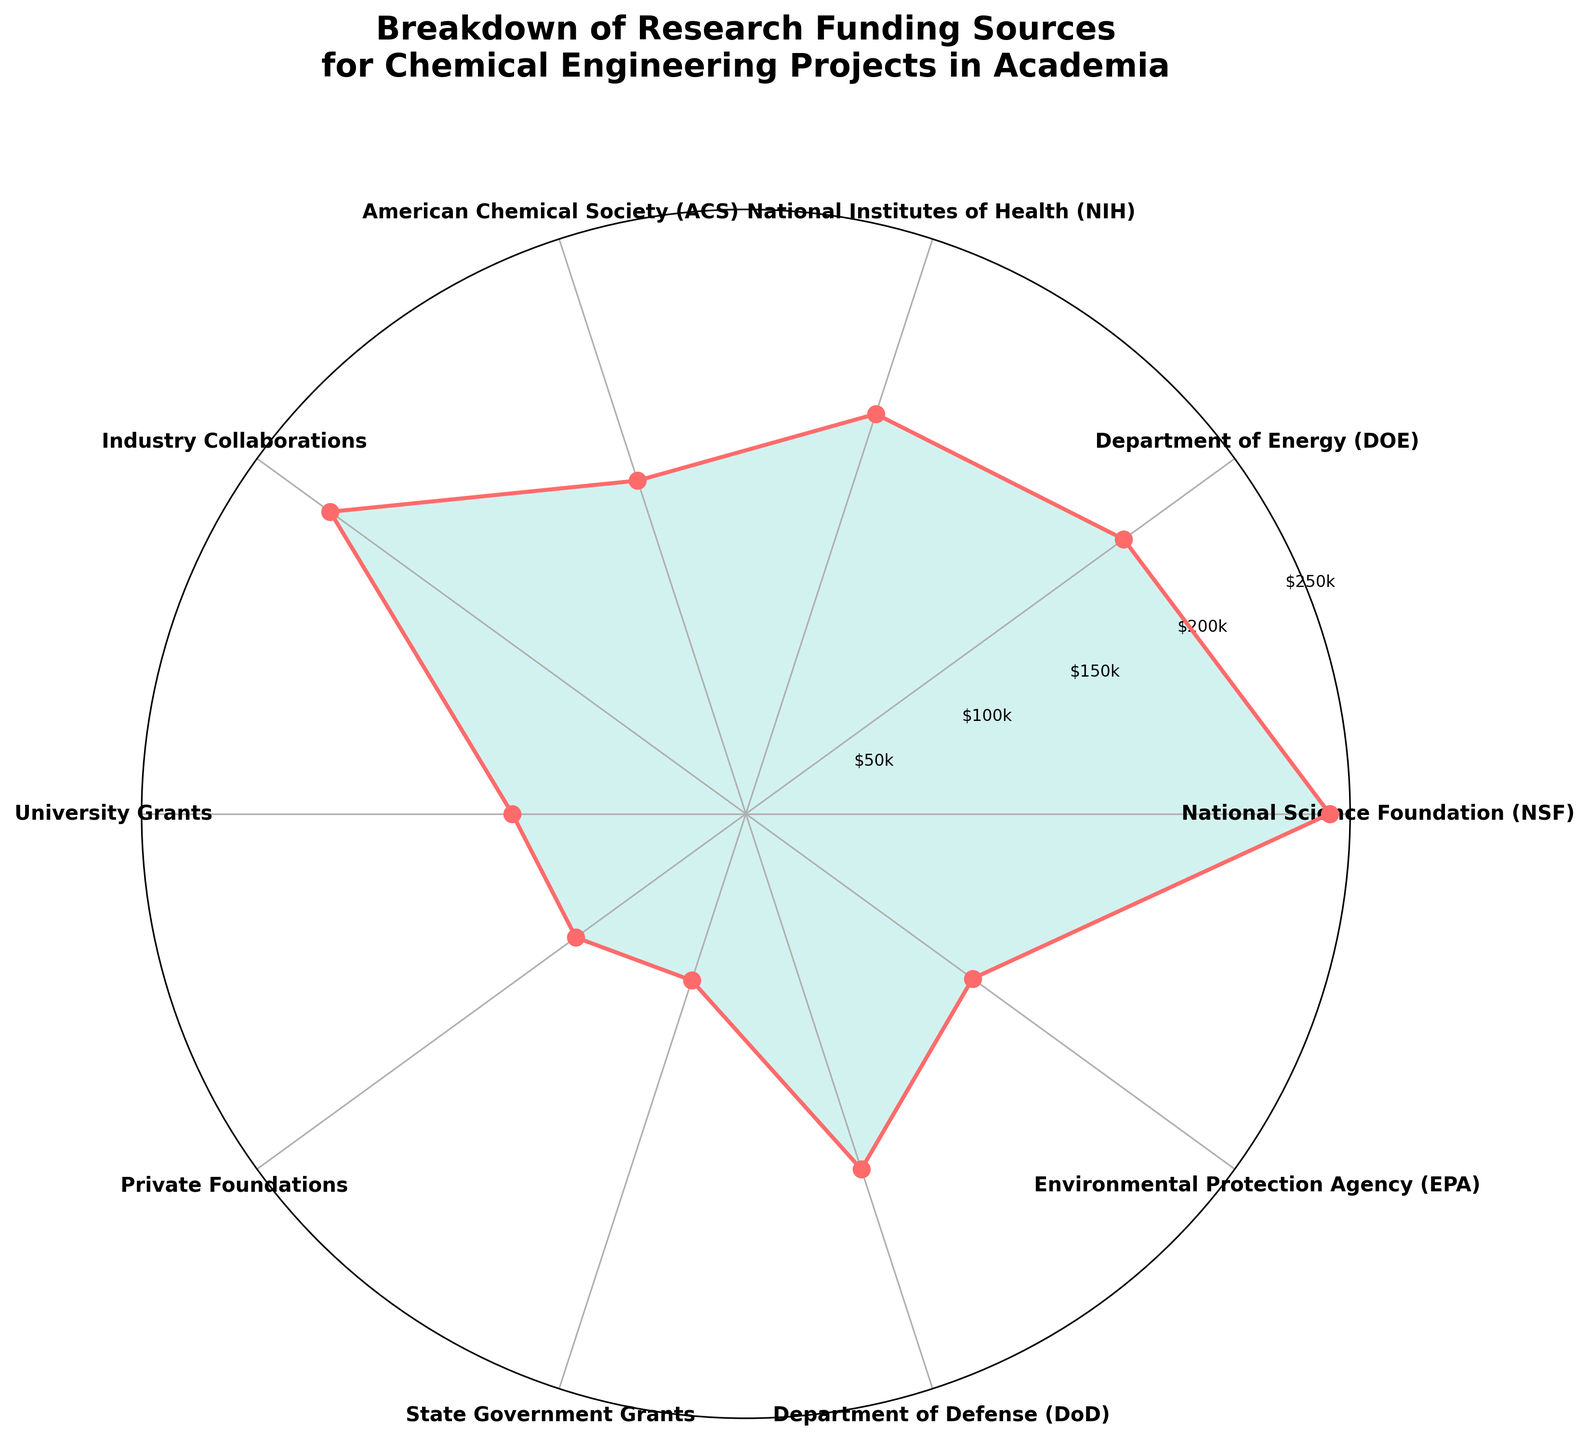What is the title of the rose chart? The title of the rose chart is written at the top. It reads "Breakdown of Research Funding Sources for Chemical Engineering Projects in Academia".
Answer: Breakdown of Research Funding Sources for Chemical Engineering Projects in Academia How many funding sources are represented in the rose chart? By counting the number of labels around the rose chart, we can see that there are 10 different funding sources represented.
Answer: 10 Which funding source has the highest amount of funding? The funding source with the highest amount will have the longest spoke in the chart. The longest spoke corresponds to the National Science Foundation (NSF) at $250k.
Answer: National Science Foundation (NSF) What is the total amount of funding represented in the chart? To find the total amount, we sum the individual amounts: 250 + 200 + 180 + 150 + 220 + 100 + 90 + 75 + 160 + 120 = 1545 ($1000).
Answer: $1545k Which funding source has the lowest amount of funding, and what is it? The shortest spoke in the rose chart represents the funding source with the lowest amount, which is State Government Grants at $75k.
Answer: State Government Grants, $75k What is the average amount of funding per source? First, find the total funding amount ($1545k) and divide it by the number of funding sources (10). The average funding is 1545k / 10 = $154.5k.
Answer: $154.5k How does the amount of funding from Industry Collaborations compare with that from the Department of Defense (DoD)? By comparing the lengths of the spokes, Industry Collaborations has $220k while the Department of Defense (DoD) has $160k. Therefore, Industry Collaborations has $60k more funding.
Answer: Industry Collaborations has $60k more Is the funding from the National Institutes of Health (NIH) greater than the funding from the Environmental Protection Agency (EPA)? By comparing the spoke lengths, NIH has $180k, while EPA has $120k. Since 180 > 120, NIH has a greater amount of funding.
Answer: Yes What percentage of the total funding is provided by the American Chemical Society (ACS)? The amount provided by ACS is $150k. To find the percentage, divide 150k by the total funding (1545k) and multiply by 100. (150/1545) * 100 ≈ 9.71%.
Answer: Approximately 9.71% How many funding sources provide more than $200k? Funding sources providing more than $200k are those with spokes longer than the $200k mark: NSF ($250k) and Industry Collaborations ($220k). There are 2 funding sources.
Answer: 2 